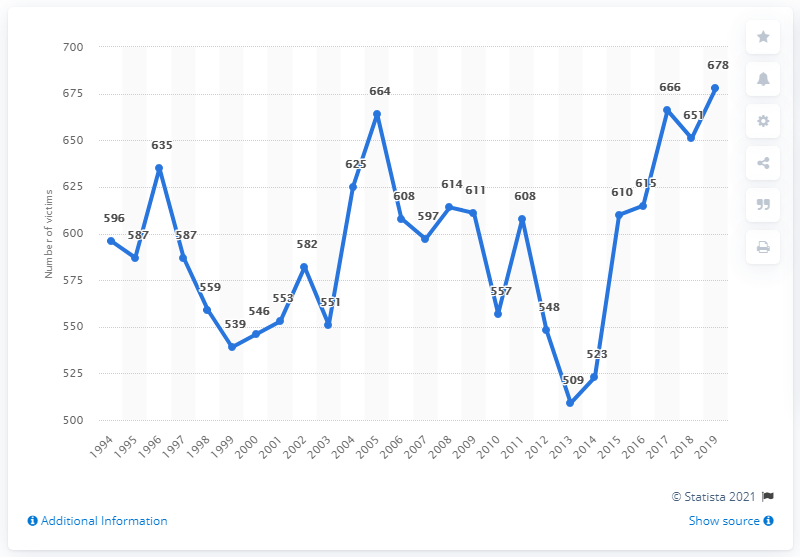Identify some key points in this picture. In 2019, there were 678 reported homicides in Canada. 